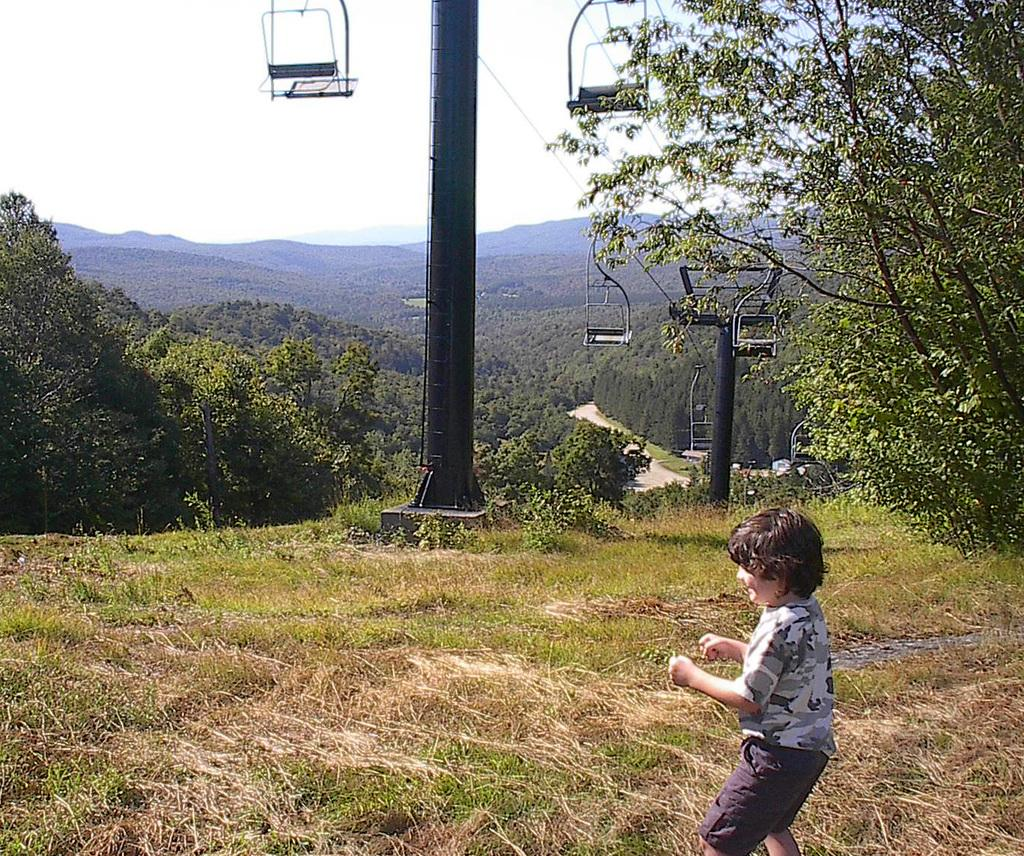What are the children doing in the image? The children are standing on the grass in the image. What type of transportation can be seen in the image? There are cable cars in the image. What structures are present in the image? There are poles in the image. What type of vegetation is visible in the image? There are plants and trees in the image. What is visible in the background of the image? The sky is visible in the background of the image. What sound do the cows make while standing on the grass in the image? There are no cows present in the image, so it is not possible to determine the sound they might make. 